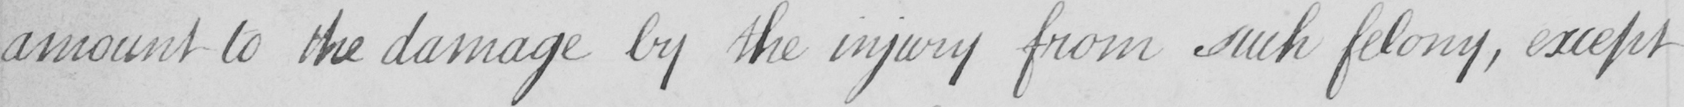What does this handwritten line say? amount to the damage by the injury from such felony , except 